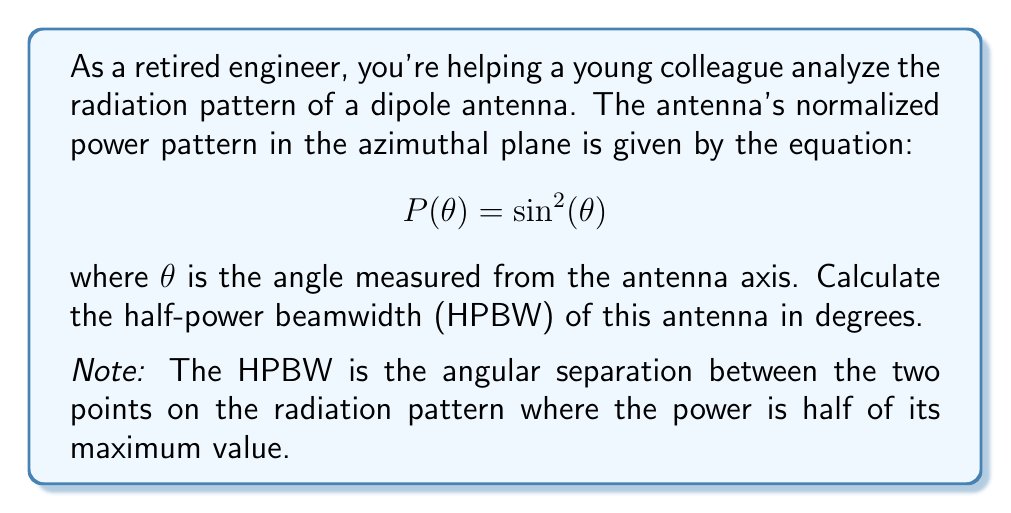Solve this math problem. To solve this problem, we'll follow these steps:

1) First, we need to find the maximum power. The maximum occurs when $\sin^2(\theta) = 1$, which happens when $\theta = 90°$ or $\frac{\pi}{2}$ radians.

2) The half-power points occur when the power is half of the maximum, i.e., when $P(\theta) = 0.5$:

   $$0.5 = \sin^2(\theta)$$

3) Solving for $\theta$:
   
   $$\sqrt{0.5} = \sin(\theta)$$
   $$\theta = \arcsin(\sqrt{0.5})$$

4) Using a calculator or remembering that $\sqrt{0.5} = \frac{\sqrt{2}}{2}$, we can find:

   $$\theta = \arcsin(\frac{\sqrt{2}}{2}) \approx 0.7854 \text{ radians}$$

5) Convert to degrees:

   $$\theta \approx 0.7854 \times \frac{180°}{\pi} \approx 45°$$

6) This angle represents the half-power point on one side of the maximum. The HPBW is twice this angle, as it includes both sides of the maximum.

   $$\text{HPBW} = 2 \times 45° = 90°$$

[asy]
import geometry;

size(200);
draw(Circle((0,0),1));
draw((-1.4,0)--(1.4,0),arrow=Arrow(TeXHead));
draw((0,-1.4)--(0,1.4),arrow=Arrow(TeXHead));
draw((0,0)--(1,0),arrow=Arrow(TeXHead),blue);
draw((0,0)--(0.707,0.707),arrow=Arrow(TeXHead),red);
draw((0,0)--(-0.707,0.707),arrow=Arrow(TeXHead),red);
draw(arc((0,0),0.5,0,45),arrow=Arrow(TeXHead),green);
draw(arc((0,0),0.5,135,180),arrow=Arrow(TeXHead),green);
label("90°", (0,0.6), N);
label("45°", (0.4,0.4), NE);
label("45°", (-0.4,0.4), NW);
label("HPBW", (0,1.2), N);
[/asy]
Answer: The half-power beamwidth (HPBW) of the dipole antenna is 90°. 